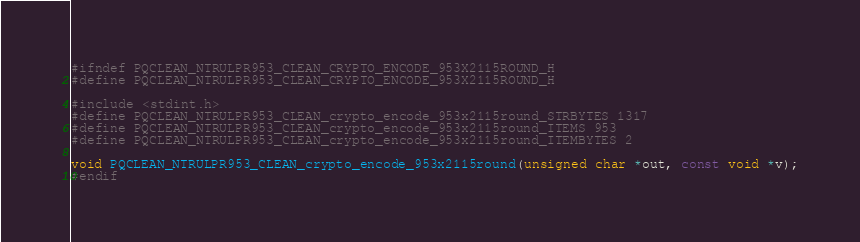Convert code to text. <code><loc_0><loc_0><loc_500><loc_500><_C_>#ifndef PQCLEAN_NTRULPR953_CLEAN_CRYPTO_ENCODE_953X2115ROUND_H
#define PQCLEAN_NTRULPR953_CLEAN_CRYPTO_ENCODE_953X2115ROUND_H

#include <stdint.h>
#define PQCLEAN_NTRULPR953_CLEAN_crypto_encode_953x2115round_STRBYTES 1317
#define PQCLEAN_NTRULPR953_CLEAN_crypto_encode_953x2115round_ITEMS 953
#define PQCLEAN_NTRULPR953_CLEAN_crypto_encode_953x2115round_ITEMBYTES 2

void PQCLEAN_NTRULPR953_CLEAN_crypto_encode_953x2115round(unsigned char *out, const void *v);
#endif
</code> 